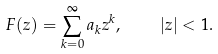Convert formula to latex. <formula><loc_0><loc_0><loc_500><loc_500>F ( z ) = \sum _ { k = 0 } ^ { \infty } a _ { k } z ^ { k } , \quad | z | < 1 .</formula> 